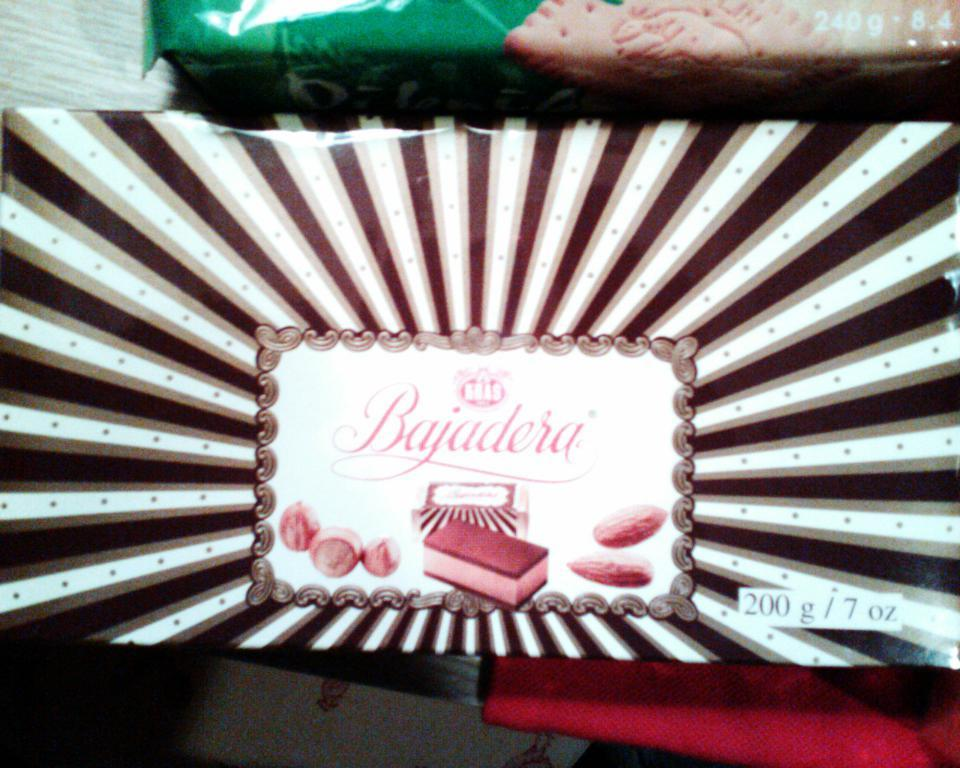What is the main subject of the image? The main subject of the image is a packet with images and text. Are there any other packets visible in the image? Yes, there is another packet at the top of the image. How many hearts can be seen in the image? There are no hearts visible in the image; it only features packets with images and text. 